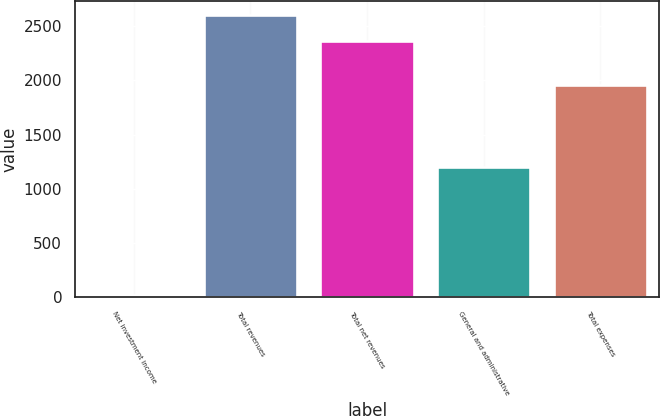Convert chart to OTSL. <chart><loc_0><loc_0><loc_500><loc_500><bar_chart><fcel>Net investment income<fcel>Total revenues<fcel>Total net revenues<fcel>General and administrative<fcel>Total expenses<nl><fcel>14<fcel>2600.2<fcel>2365<fcel>1201<fcel>1955<nl></chart> 